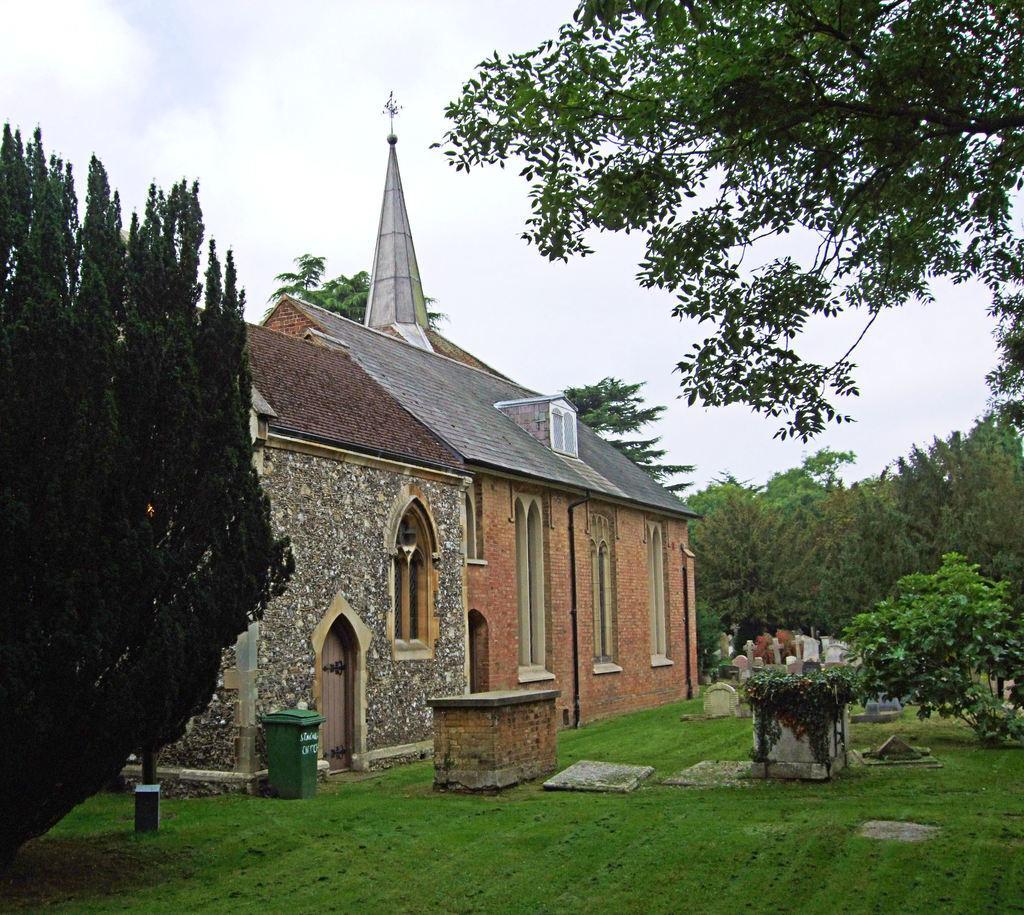Describe this image in one or two sentences. In this image we can see trees on the left and right side. In the background there are houses, windows, dustbin, grass, plants, graveyard, trees and clouds in the sky. 